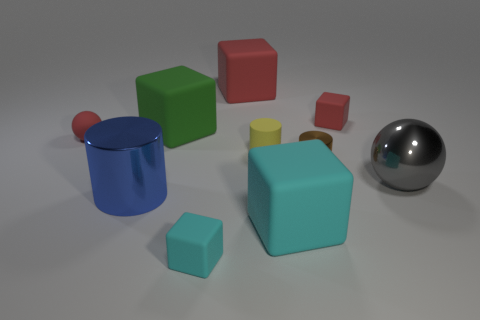Subtract all small rubber cubes. How many cubes are left? 3 Subtract all red cylinders. How many red blocks are left? 2 Subtract all red cubes. How many cubes are left? 3 Subtract 1 cubes. How many cubes are left? 4 Subtract 0 gray cylinders. How many objects are left? 10 Subtract all cylinders. How many objects are left? 7 Subtract all purple balls. Subtract all brown cylinders. How many balls are left? 2 Subtract all big cylinders. Subtract all tiny yellow things. How many objects are left? 8 Add 1 small red matte objects. How many small red matte objects are left? 3 Add 9 purple objects. How many purple objects exist? 9 